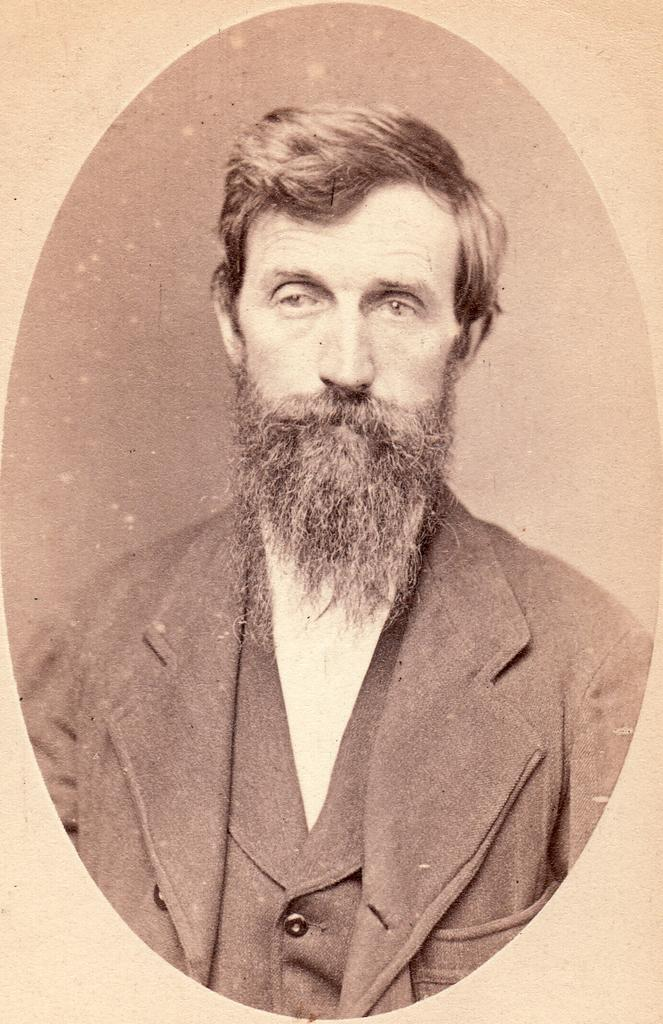What object is present in the image that typically holds a picture? There is a photo frame in the image. What can be seen inside the photo frame? The photo frame contains a picture of a man. What type of beam is holding up the desk in the image? There is no desk or beam present in the image; it only features a photo frame with a picture of a man. 